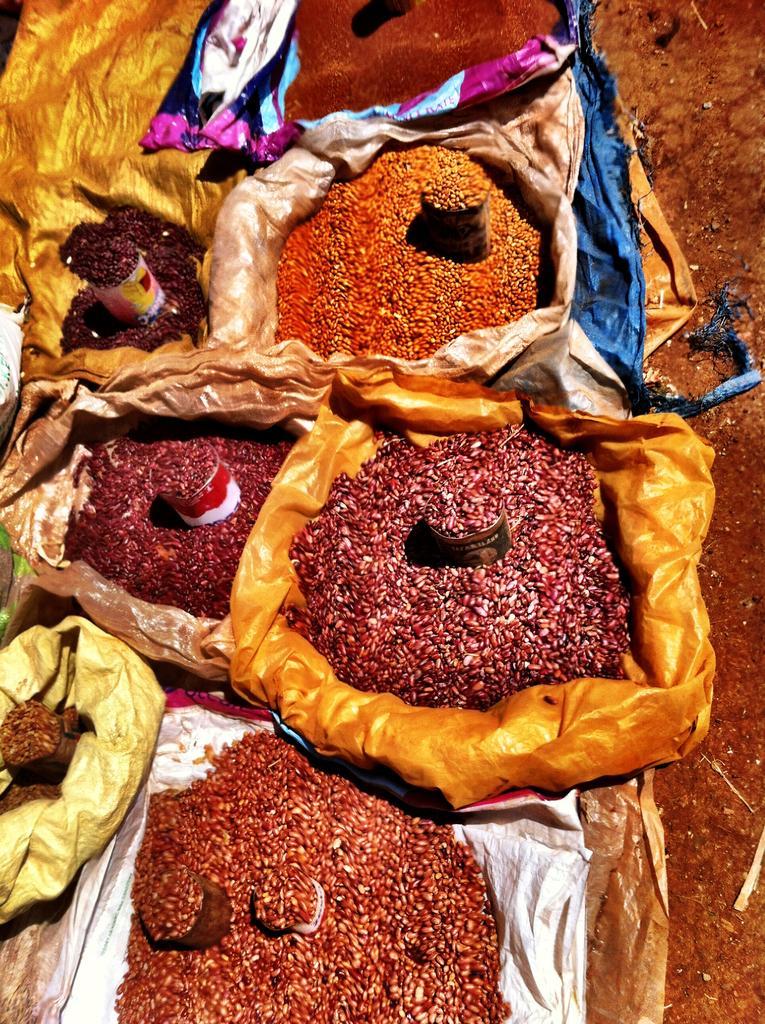Please provide a concise description of this image. In this image I can see few clothes which are gold, black, pink and white in color and on the clothes I can see few grains which are brown, orange, red in color and I can see few containers in which I can see the grains. To the right side of the image I can see the ground. 